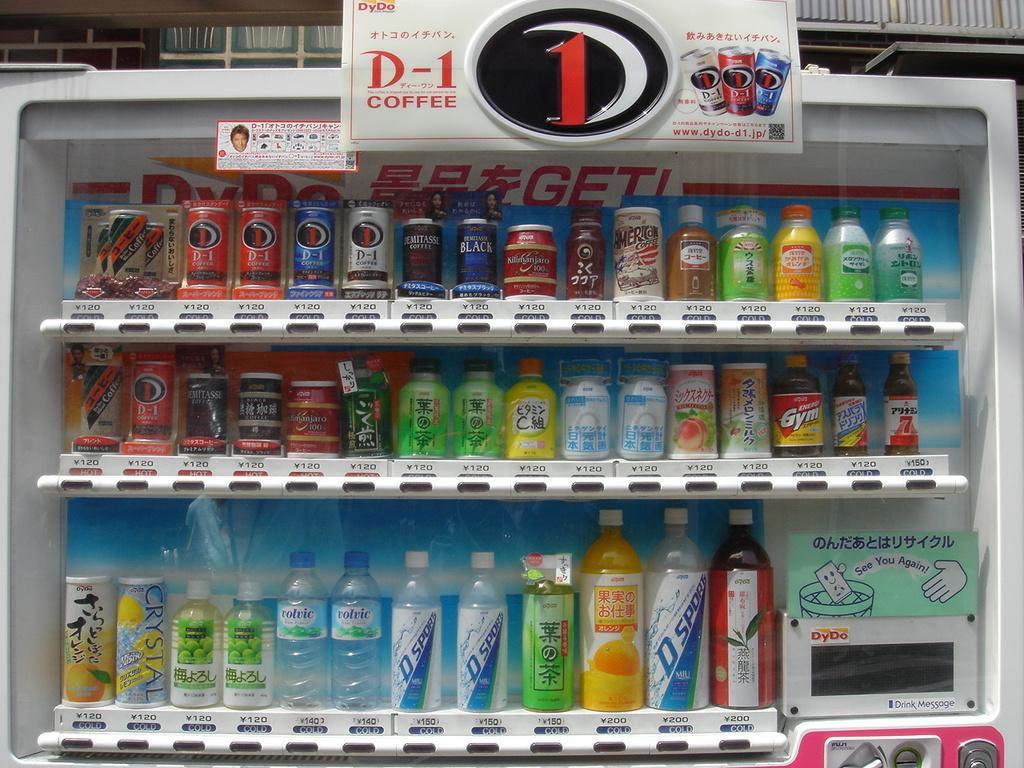<image>
Summarize the visual content of the image. A row of drinks for sale in a cooler that says D-1 Coffee. 